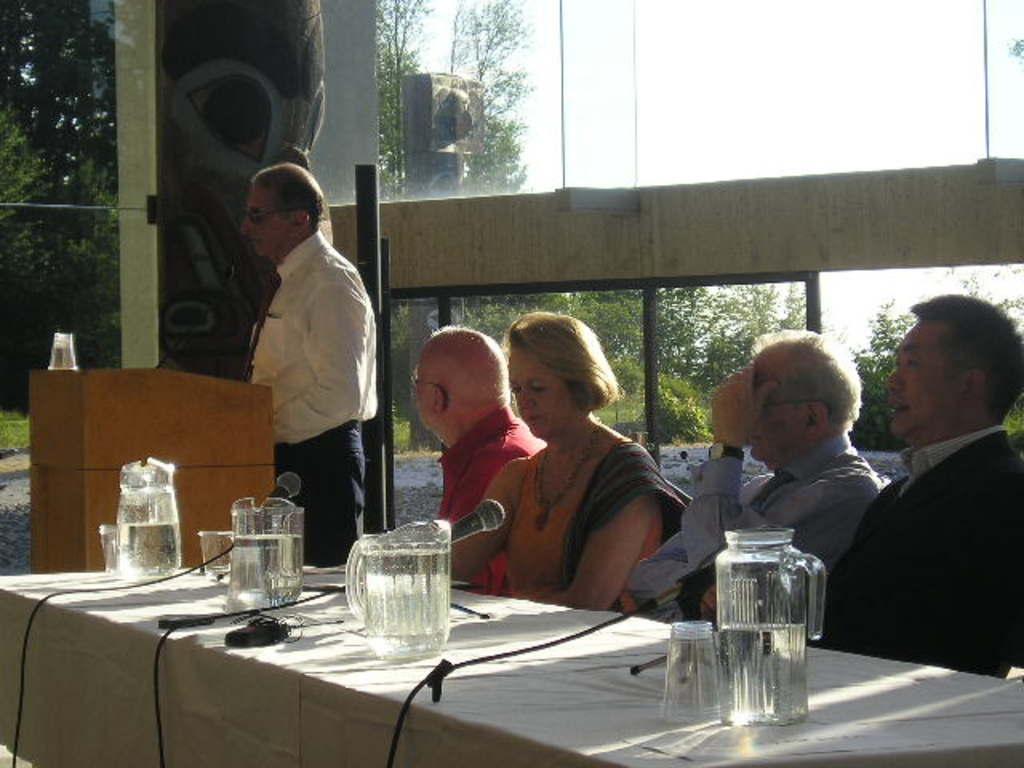Could you give a brief overview of what you see in this image? In this picture the are group of people who are sitting on a chair and, on the left side there is one person who is standing. In front of him there is one podium and mic and in the bottom there is one table on that table there are some jars,and glasses and mikes are there and on the top there is a glass window and on the left side there are some trees. 